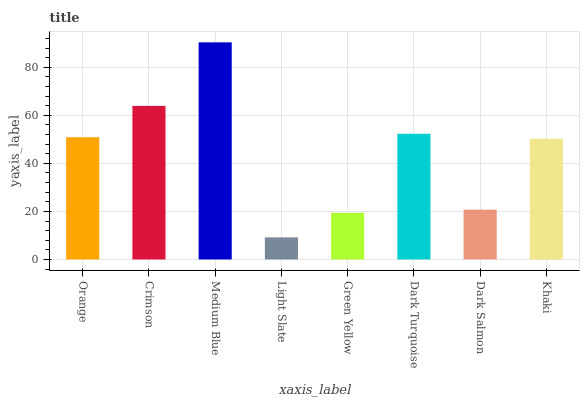Is Crimson the minimum?
Answer yes or no. No. Is Crimson the maximum?
Answer yes or no. No. Is Crimson greater than Orange?
Answer yes or no. Yes. Is Orange less than Crimson?
Answer yes or no. Yes. Is Orange greater than Crimson?
Answer yes or no. No. Is Crimson less than Orange?
Answer yes or no. No. Is Orange the high median?
Answer yes or no. Yes. Is Khaki the low median?
Answer yes or no. Yes. Is Green Yellow the high median?
Answer yes or no. No. Is Dark Salmon the low median?
Answer yes or no. No. 